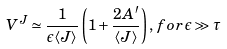<formula> <loc_0><loc_0><loc_500><loc_500>V ^ { J } \simeq \frac { 1 } { \epsilon \langle J \rangle } \left ( 1 + \frac { 2 A ^ { \prime } } { \langle J \rangle } \right ) , \, f o r \, \epsilon \gg \tau</formula> 